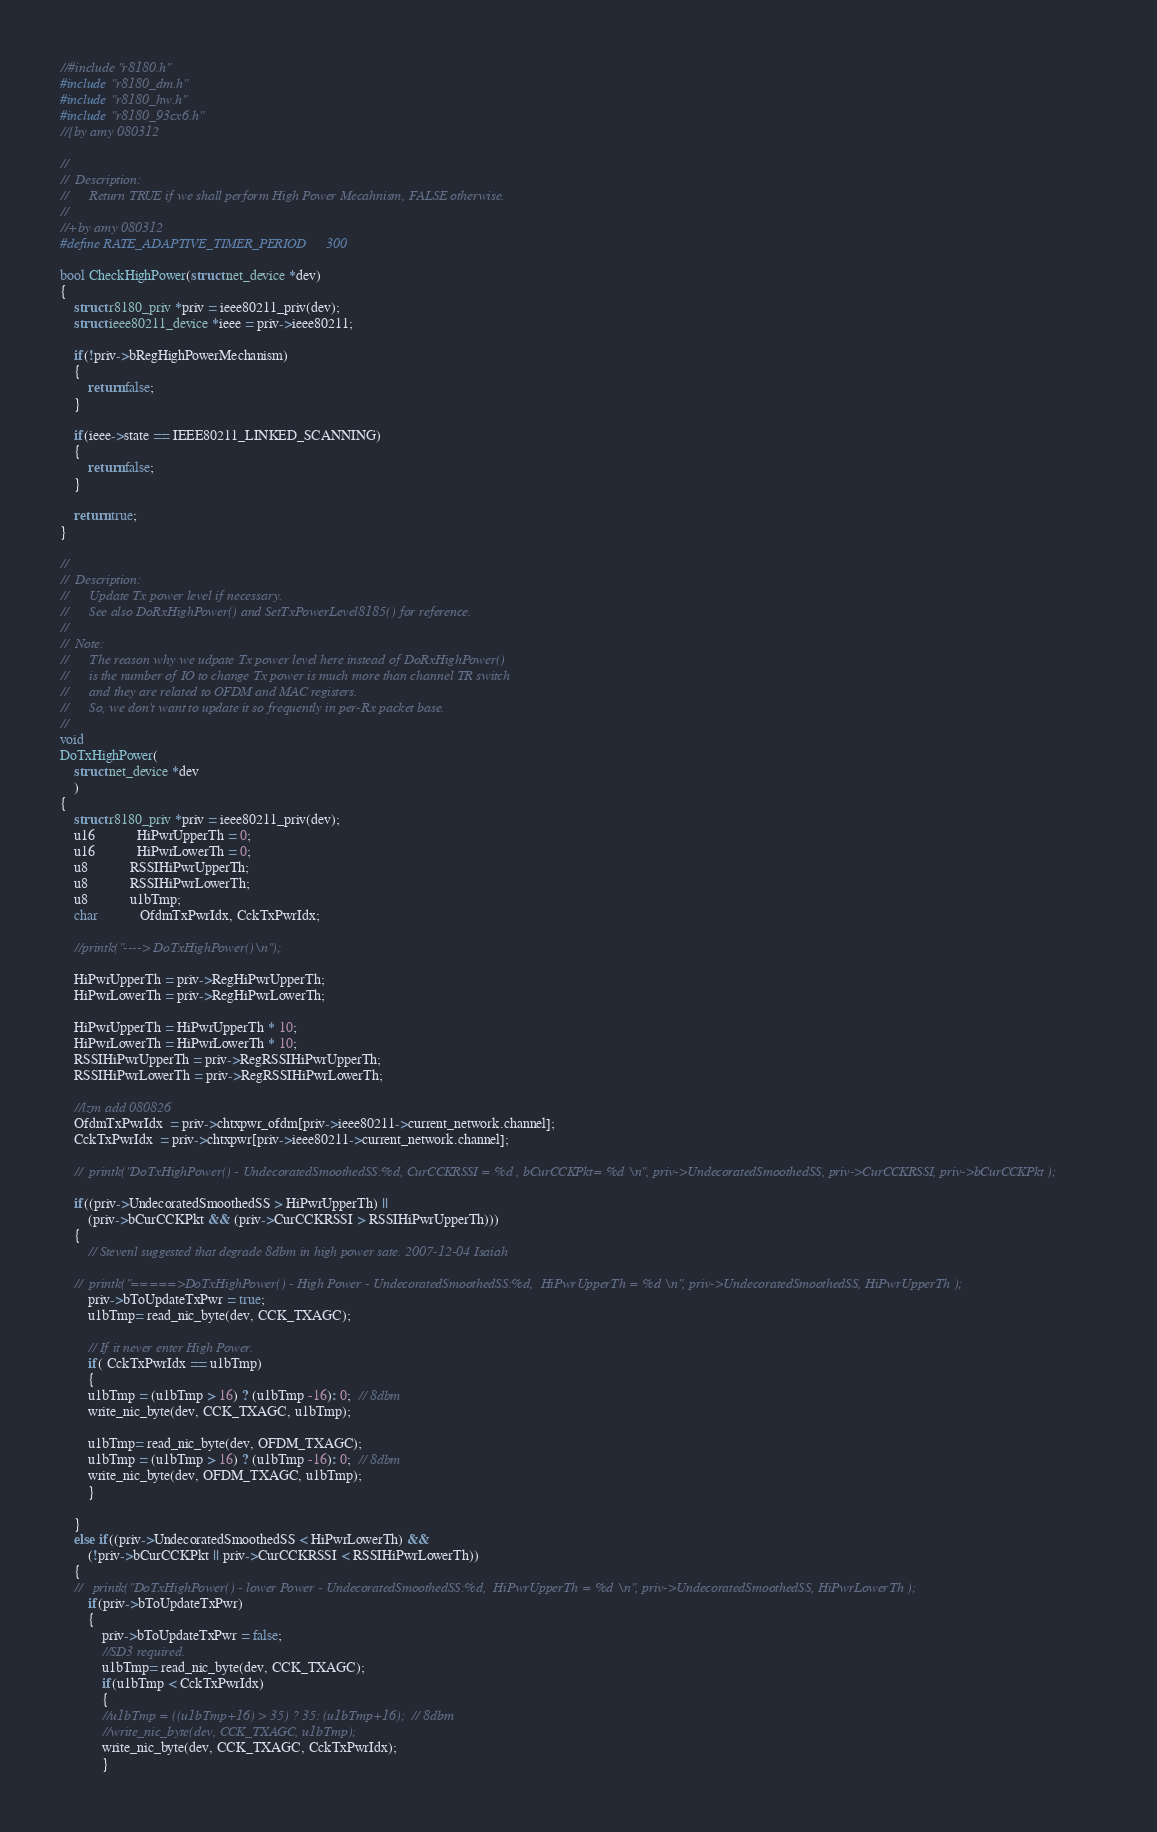Convert code to text. <code><loc_0><loc_0><loc_500><loc_500><_C_>//#include "r8180.h"
#include "r8180_dm.h"
#include "r8180_hw.h"
#include "r8180_93cx6.h"
//{by amy 080312

//
//	Description:
//		Return TRUE if we shall perform High Power Mecahnism, FALSE otherwise.
//
//+by amy 080312
#define RATE_ADAPTIVE_TIMER_PERIOD      300

bool CheckHighPower(struct net_device *dev)
{
	struct r8180_priv *priv = ieee80211_priv(dev);
	struct ieee80211_device *ieee = priv->ieee80211;

	if(!priv->bRegHighPowerMechanism)
	{
		return false;
	}

	if(ieee->state == IEEE80211_LINKED_SCANNING)
	{
		return false;
	}

	return true;
}

//
//	Description:
//		Update Tx power level if necessary.
//		See also DoRxHighPower() and SetTxPowerLevel8185() for reference.
//
//	Note:
//		The reason why we udpate Tx power level here instead of DoRxHighPower()
//		is the number of IO to change Tx power is much more than channel TR switch
//		and they are related to OFDM and MAC registers.
//		So, we don't want to update it so frequently in per-Rx packet base.
//
void
DoTxHighPower(
	struct net_device *dev
	)
{
	struct r8180_priv *priv = ieee80211_priv(dev);
	u16			HiPwrUpperTh = 0;
	u16			HiPwrLowerTh = 0;
	u8			RSSIHiPwrUpperTh;
	u8			RSSIHiPwrLowerTh;
	u8			u1bTmp;
	char			OfdmTxPwrIdx, CckTxPwrIdx;

	//printk("----> DoTxHighPower()\n");

	HiPwrUpperTh = priv->RegHiPwrUpperTh;
	HiPwrLowerTh = priv->RegHiPwrLowerTh;

	HiPwrUpperTh = HiPwrUpperTh * 10;
	HiPwrLowerTh = HiPwrLowerTh * 10;
	RSSIHiPwrUpperTh = priv->RegRSSIHiPwrUpperTh;
	RSSIHiPwrLowerTh = priv->RegRSSIHiPwrLowerTh;

	//lzm add 080826
	OfdmTxPwrIdx  = priv->chtxpwr_ofdm[priv->ieee80211->current_network.channel];
	CckTxPwrIdx  = priv->chtxpwr[priv->ieee80211->current_network.channel];

	//	printk("DoTxHighPower() - UndecoratedSmoothedSS:%d, CurCCKRSSI = %d , bCurCCKPkt= %d \n", priv->UndecoratedSmoothedSS, priv->CurCCKRSSI, priv->bCurCCKPkt );

	if((priv->UndecoratedSmoothedSS > HiPwrUpperTh) ||
		(priv->bCurCCKPkt && (priv->CurCCKRSSI > RSSIHiPwrUpperTh)))
	{
		// Stevenl suggested that degrade 8dbm in high power sate. 2007-12-04 Isaiah

	//	printk("=====>DoTxHighPower() - High Power - UndecoratedSmoothedSS:%d,  HiPwrUpperTh = %d \n", priv->UndecoratedSmoothedSS, HiPwrUpperTh );
		priv->bToUpdateTxPwr = true;
		u1bTmp= read_nic_byte(dev, CCK_TXAGC);

		// If it never enter High Power.
		if( CckTxPwrIdx == u1bTmp)
		{
		u1bTmp = (u1bTmp > 16) ? (u1bTmp -16): 0;  // 8dbm
		write_nic_byte(dev, CCK_TXAGC, u1bTmp);

		u1bTmp= read_nic_byte(dev, OFDM_TXAGC);
		u1bTmp = (u1bTmp > 16) ? (u1bTmp -16): 0;  // 8dbm
		write_nic_byte(dev, OFDM_TXAGC, u1bTmp);
		}

	}
	else if((priv->UndecoratedSmoothedSS < HiPwrLowerTh) &&
		(!priv->bCurCCKPkt || priv->CurCCKRSSI < RSSIHiPwrLowerTh))
	{
	//	 printk("DoTxHighPower() - lower Power - UndecoratedSmoothedSS:%d,  HiPwrUpperTh = %d \n", priv->UndecoratedSmoothedSS, HiPwrLowerTh );
		if(priv->bToUpdateTxPwr)
		{
			priv->bToUpdateTxPwr = false;
			//SD3 required.
			u1bTmp= read_nic_byte(dev, CCK_TXAGC);
			if(u1bTmp < CckTxPwrIdx)
			{
			//u1bTmp = ((u1bTmp+16) > 35) ? 35: (u1bTmp+16);  // 8dbm
			//write_nic_byte(dev, CCK_TXAGC, u1bTmp);
			write_nic_byte(dev, CCK_TXAGC, CckTxPwrIdx);
			}
</code> 